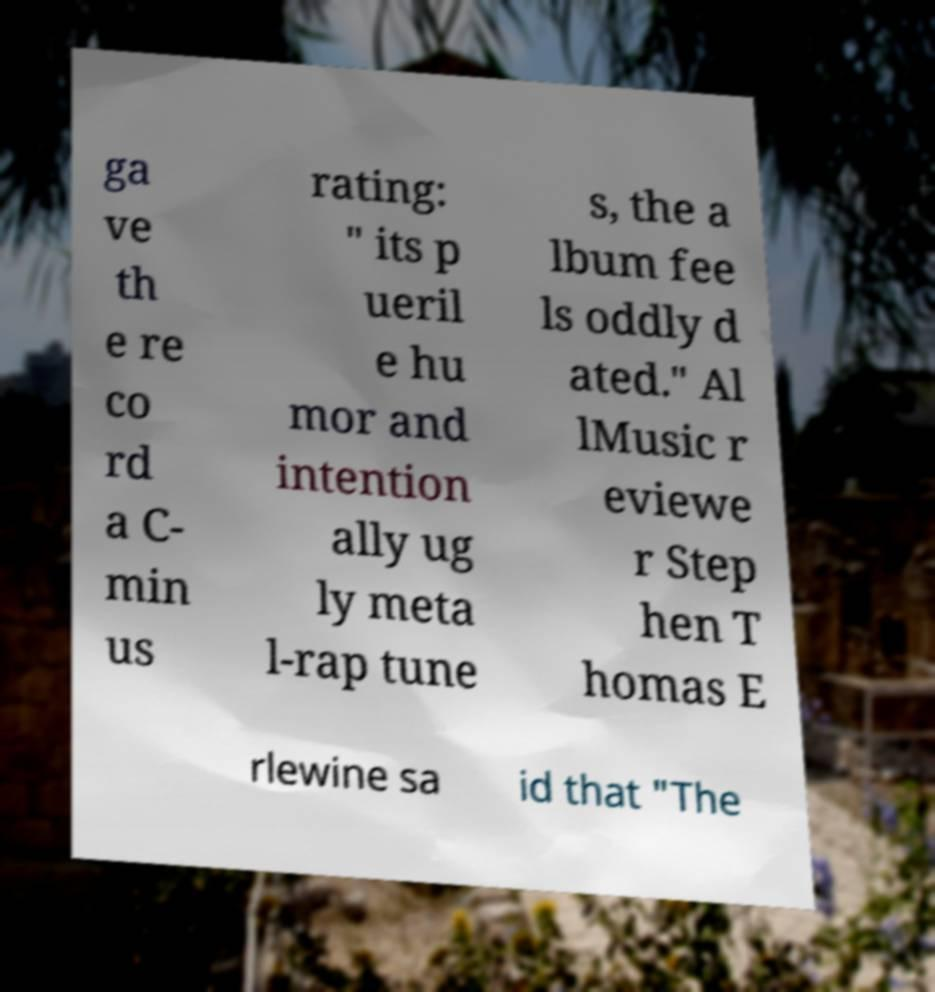Can you read and provide the text displayed in the image?This photo seems to have some interesting text. Can you extract and type it out for me? ga ve th e re co rd a C- min us rating: " its p ueril e hu mor and intention ally ug ly meta l-rap tune s, the a lbum fee ls oddly d ated." Al lMusic r eviewe r Step hen T homas E rlewine sa id that "The 